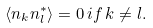<formula> <loc_0><loc_0><loc_500><loc_500>\left < n _ { k } n _ { l } ^ { * } \right > = 0 \, i f \, k \neq l .</formula> 